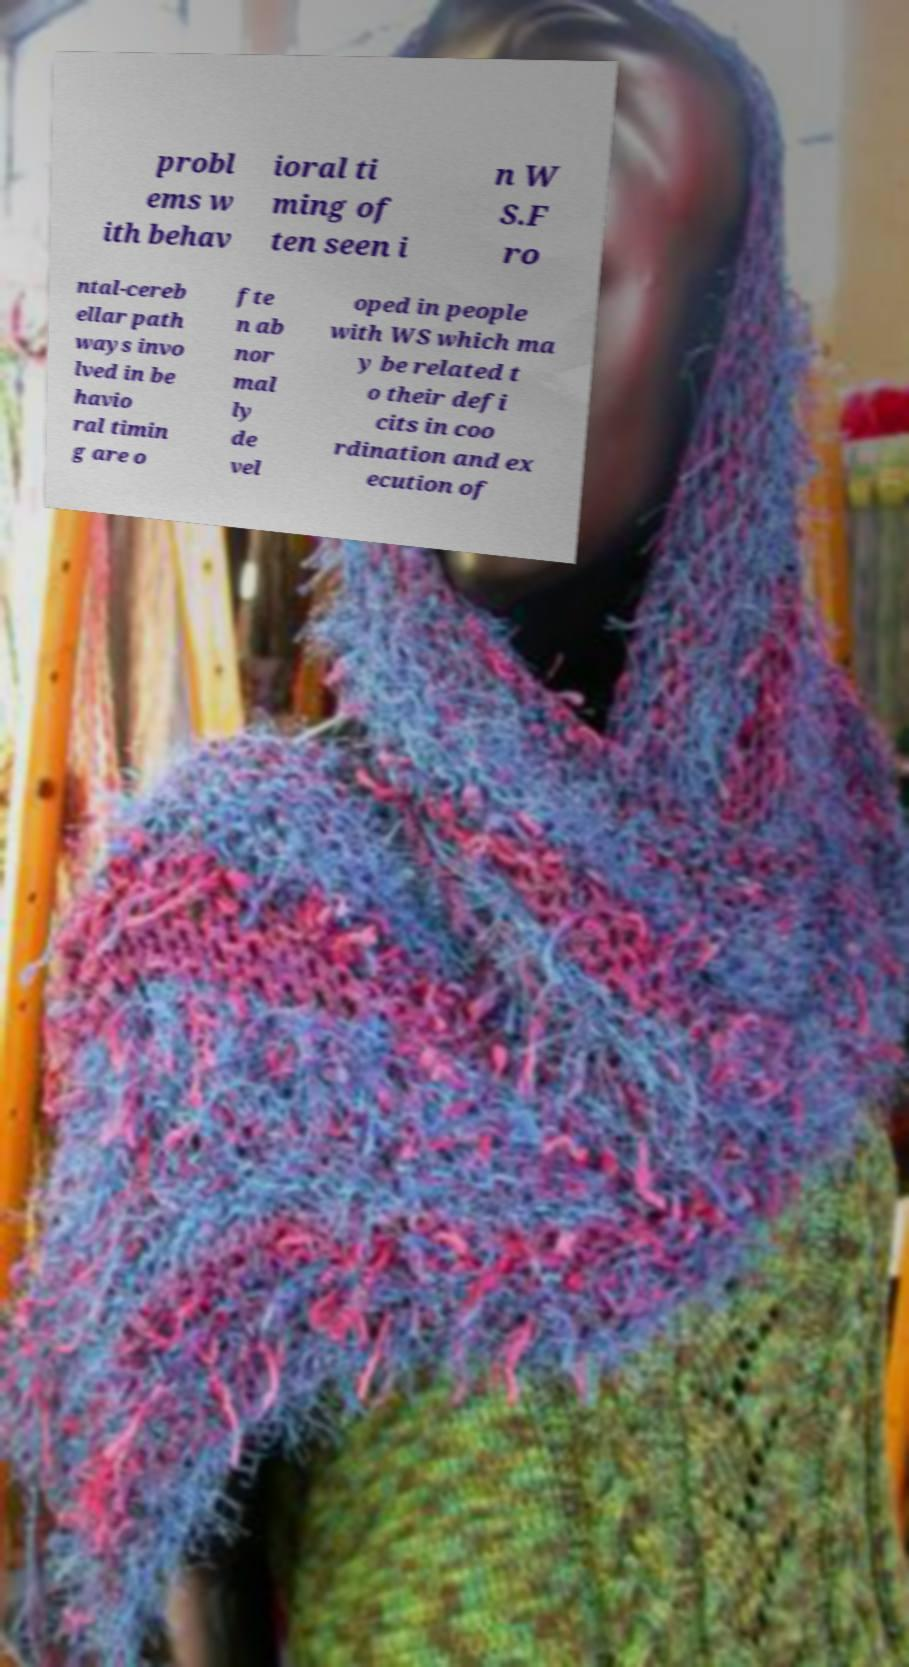What messages or text are displayed in this image? I need them in a readable, typed format. probl ems w ith behav ioral ti ming of ten seen i n W S.F ro ntal-cereb ellar path ways invo lved in be havio ral timin g are o fte n ab nor mal ly de vel oped in people with WS which ma y be related t o their defi cits in coo rdination and ex ecution of 